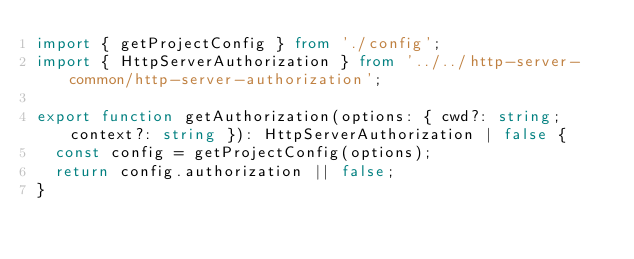<code> <loc_0><loc_0><loc_500><loc_500><_TypeScript_>import { getProjectConfig } from './config';
import { HttpServerAuthorization } from '../../http-server-common/http-server-authorization';

export function getAuthorization(options: { cwd?: string; context?: string }): HttpServerAuthorization | false {
  const config = getProjectConfig(options);
  return config.authorization || false;
}
</code> 